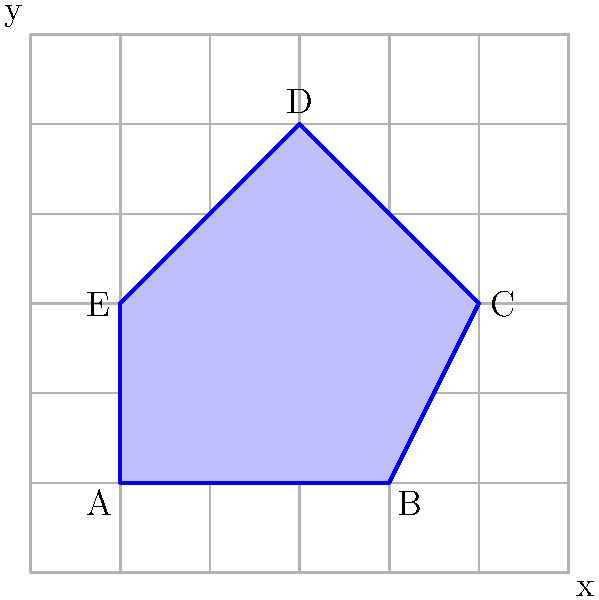Your neighbor, who enjoys peaceful activities like gardening, has a uniquely shaped flowerbed in their backyard. The flowerbed's shape is represented by the blue polygon ABCDE on the grid, where each square represents 1 square meter. Calculate the area of this flowerbed to help your neighbor determine how much mulch they need to cover it. To find the area of this irregular polygon, we can use the grid method. This method involves counting the number of whole squares inside the polygon and estimating the fractional parts of squares along the edges. Let's break it down step-by-step:

1. Count whole squares:
   There are 8 whole squares completely inside the polygon.

2. Estimate partial squares:
   - Along AB: approximately 1.5 squares
   - Along BC: approximately 1 square
   - Along CD: approximately 1.5 squares
   - Along DE: approximately 1 square
   - Along EA: approximately 1 square

3. Sum up the areas:
   Total area ≈ 8 (whole squares) + 1.5 + 1 + 1.5 + 1 + 1 (partial squares)
               ≈ 8 + 6 = 14 square units

4. Since each square represents 1 square meter:
   Area of the flowerbed ≈ 14 square meters

This method provides a good approximation of the area. For more precise calculations, one could use more advanced techniques like the Shoelace formula or dividing the shape into triangles, but this grid method is sufficient for estimating the amount of mulch needed.
Answer: 14 square meters 